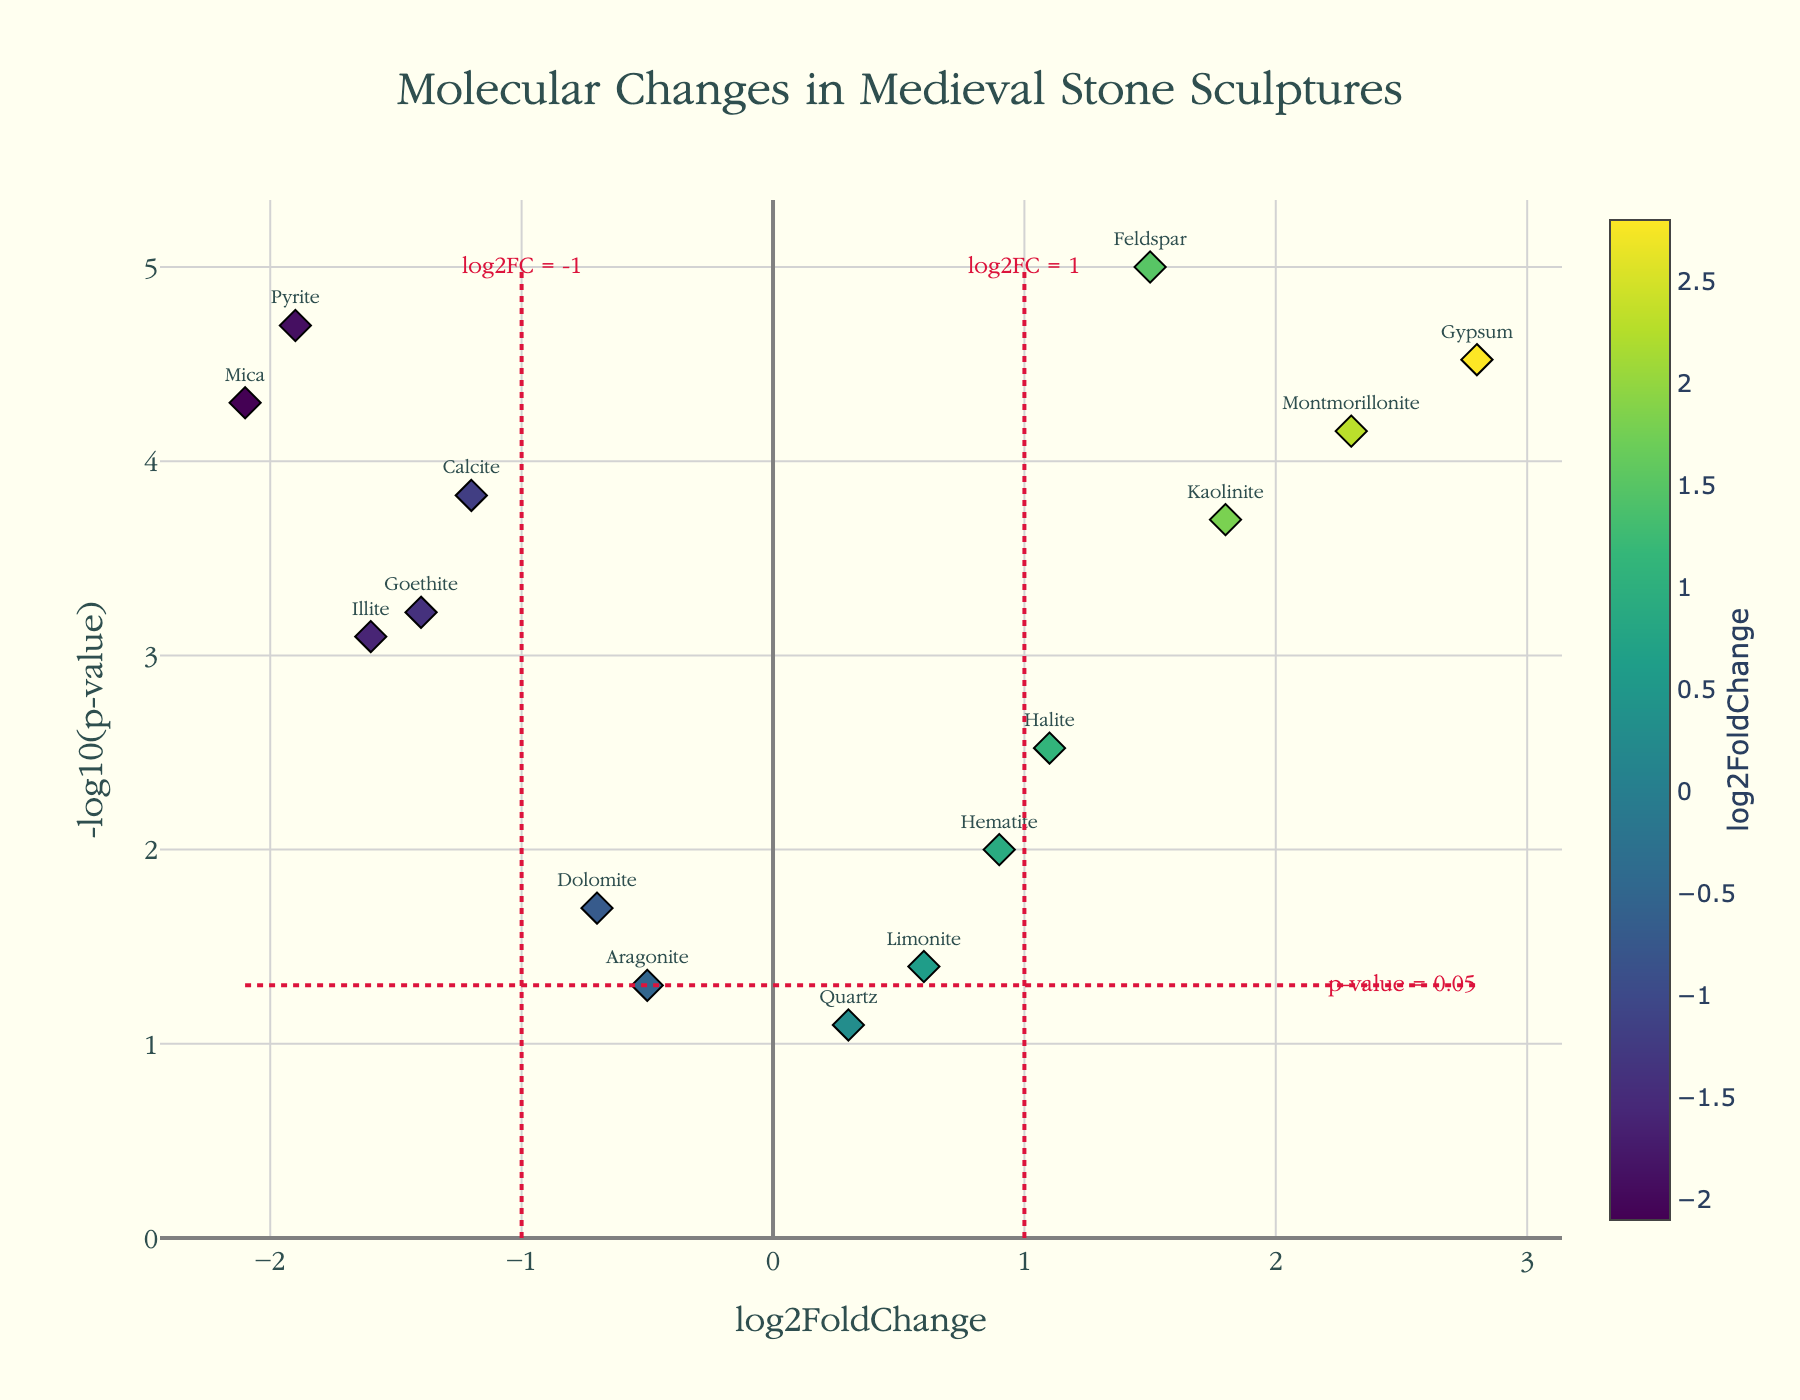What is the title of the volcano plot? The title is typically displayed prominently at the top of the plot, indicating the primary subject of the visualization. In this case, it reads, "Molecular Changes in Medieval Stone Sculptures".
Answer: Molecular Changes in Medieval Stone Sculptures How many molecules have a significant p-value of less than 0.05? To determine this, look at the y-axis, which represents the -log10(p-value). A p-value less than 0.05 corresponds to a -log10(p-value) greater than 1.3. Count the number of points (molecules) that fall above this threshold. There are 11 points above the threshold line.
Answer: 11 Which molecule shows the highest log2FoldChange? The log2FoldChange is represented on the x-axis. Find the point with the highest x-value. From the plot, Gypsum shows the highest log2FoldChange of 2.8.
Answer: Gypsum Which molecule has the lowest -log10(p-value), and what is its p-value? The -log10(p-value) is shown on the y-axis. Find the point with the smallest y-value. Quartz has the lowest -log10(p-value). To find its p-value, convert from -log10(p-value): 10^-0.08 ≈ 0.83.
Answer: Quartz, 0.83 Between Calcite and Goethite, which molecule has a greater log2FoldChange? Compare the x-values of the points labeled Calcite and Goethite. Calcite has a log2FoldChange of -1.2, while Goethite has a log2FoldChange of -1.4. Since -1.2 > -1.4, Calcite has the greater log2FoldChange.
Answer: Calcite Which molecules fall outside the typical threshold lines at log2FC = ±1 and -log10(p-value) = 1.3? Identify points outside the vertical thresholds (log2FoldChange > 1 or < -1) and the horizontal threshold (-log10(p-value) > 1.3). These include: Calcite, Gypsum, Feldspar, Mica, Kaolinite, Illite, Montmorillonite, Pyrite, Goethite.
Answer: Calcite, Gypsum, Feldspar, Mica, Kaolinite, Illite, Montmorillonite, Pyrite, Goethite What horizontal line color represents the significance threshold for the p-value? The horizontal line indicates the significance threshold for the p-value, and it is colored crimson. Look at the line running across the plot at -log10(p-value) = 1.3, and note the color.
Answer: crimson Which molecule closest to the origin (0, 0) on the plot, and what's its log2FoldChange and p-value? Identify the point closest to the (0, 0) coordinates. Quartz is nearest to the origin with a log2FoldChange of 0.3 and p-value of 0.08.
Answer: Quartz, 0.3, 0.08 